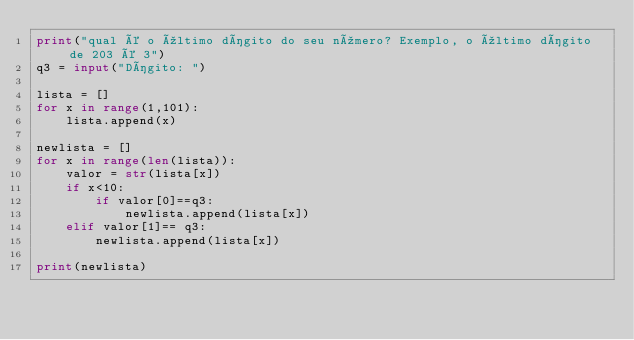Convert code to text. <code><loc_0><loc_0><loc_500><loc_500><_Python_>print("qual é o último dígito do seu número? Exemplo, o último dígito de 203 é 3")
q3 = input("Dígito: ")

lista = []
for x in range(1,101):
    lista.append(x)

newlista = []
for x in range(len(lista)):
    valor = str(lista[x])
    if x<10:
        if valor[0]==q3:
            newlista.append(lista[x])
    elif valor[1]== q3:
        newlista.append(lista[x])

print(newlista)</code> 